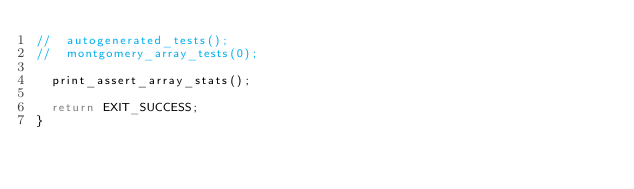Convert code to text. <code><loc_0><loc_0><loc_500><loc_500><_C_>//  autogenerated_tests();
//  montgomery_array_tests(0);

  print_assert_array_stats();

  return EXIT_SUCCESS;
}
</code> 